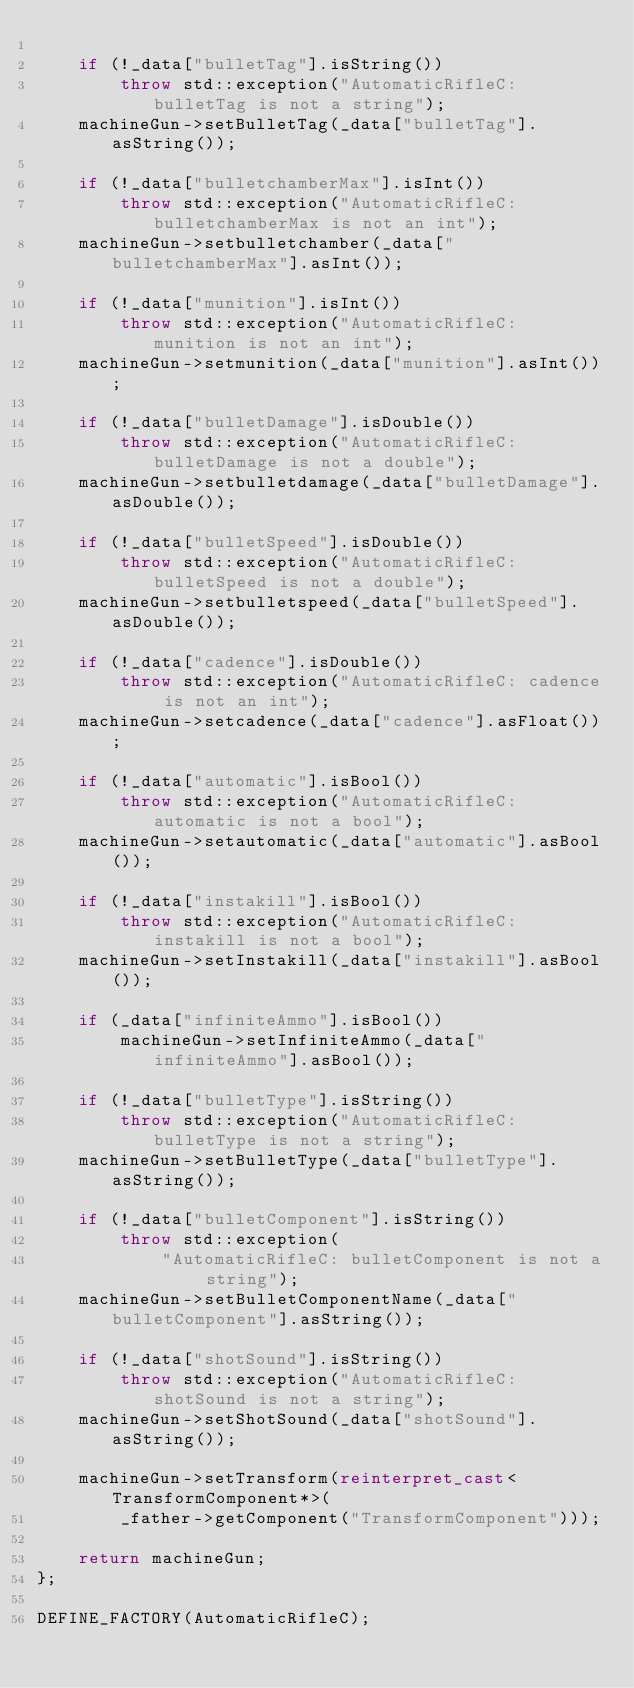Convert code to text. <code><loc_0><loc_0><loc_500><loc_500><_C++_>
    if (!_data["bulletTag"].isString())
        throw std::exception("AutomaticRifleC: bulletTag is not a string");
    machineGun->setBulletTag(_data["bulletTag"].asString());

    if (!_data["bulletchamberMax"].isInt())
        throw std::exception("AutomaticRifleC: bulletchamberMax is not an int");
    machineGun->setbulletchamber(_data["bulletchamberMax"].asInt());

    if (!_data["munition"].isInt())
        throw std::exception("AutomaticRifleC: munition is not an int");
    machineGun->setmunition(_data["munition"].asInt());

    if (!_data["bulletDamage"].isDouble())
        throw std::exception("AutomaticRifleC: bulletDamage is not a double");
    machineGun->setbulletdamage(_data["bulletDamage"].asDouble());

    if (!_data["bulletSpeed"].isDouble())
        throw std::exception("AutomaticRifleC: bulletSpeed is not a double");
    machineGun->setbulletspeed(_data["bulletSpeed"].asDouble());

    if (!_data["cadence"].isDouble())
        throw std::exception("AutomaticRifleC: cadence is not an int");
    machineGun->setcadence(_data["cadence"].asFloat());

    if (!_data["automatic"].isBool())
        throw std::exception("AutomaticRifleC: automatic is not a bool");
    machineGun->setautomatic(_data["automatic"].asBool());

    if (!_data["instakill"].isBool())
        throw std::exception("AutomaticRifleC: instakill is not a bool");
    machineGun->setInstakill(_data["instakill"].asBool());

    if (_data["infiniteAmmo"].isBool())
        machineGun->setInfiniteAmmo(_data["infiniteAmmo"].asBool());

    if (!_data["bulletType"].isString())
        throw std::exception("AutomaticRifleC: bulletType is not a string");
    machineGun->setBulletType(_data["bulletType"].asString());

    if (!_data["bulletComponent"].isString())
        throw std::exception(
            "AutomaticRifleC: bulletComponent is not a string");
    machineGun->setBulletComponentName(_data["bulletComponent"].asString());

    if (!_data["shotSound"].isString())
        throw std::exception("AutomaticRifleC: shotSound is not a string");
    machineGun->setShotSound(_data["shotSound"].asString());

    machineGun->setTransform(reinterpret_cast<TransformComponent*>(
        _father->getComponent("TransformComponent")));

    return machineGun;
};

DEFINE_FACTORY(AutomaticRifleC);
</code> 